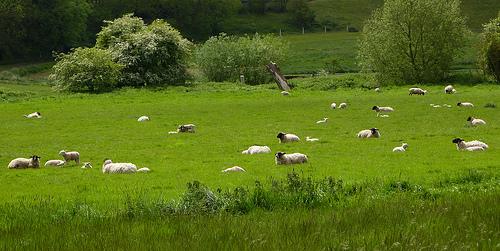Are any of the animals standing up?
Keep it brief. Yes. What kind of animals are these?
Be succinct. Sheep. Does it appear that it is a clear day?
Concise answer only. Yes. 